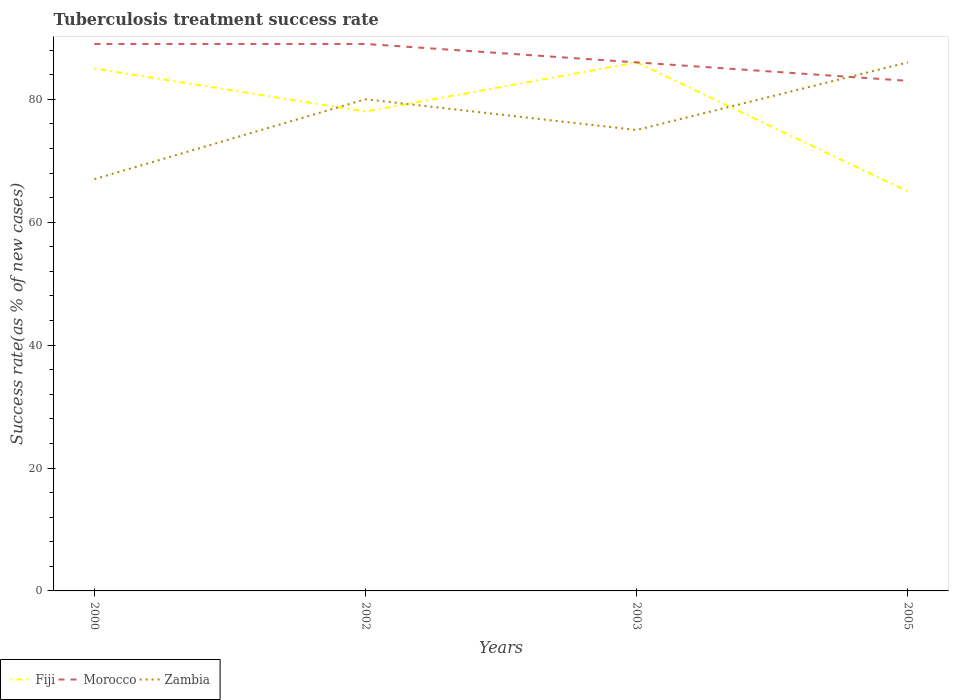How many different coloured lines are there?
Your answer should be compact. 3. Across all years, what is the maximum tuberculosis treatment success rate in Morocco?
Keep it short and to the point. 83. What is the total tuberculosis treatment success rate in Morocco in the graph?
Keep it short and to the point. 3. What is the difference between the highest and the second highest tuberculosis treatment success rate in Morocco?
Your response must be concise. 6. What is the difference between the highest and the lowest tuberculosis treatment success rate in Fiji?
Offer a very short reply. 2. Is the tuberculosis treatment success rate in Zambia strictly greater than the tuberculosis treatment success rate in Morocco over the years?
Offer a terse response. No. How many lines are there?
Give a very brief answer. 3. Does the graph contain grids?
Ensure brevity in your answer.  No. Where does the legend appear in the graph?
Make the answer very short. Bottom left. How many legend labels are there?
Make the answer very short. 3. What is the title of the graph?
Your answer should be very brief. Tuberculosis treatment success rate. What is the label or title of the X-axis?
Your answer should be very brief. Years. What is the label or title of the Y-axis?
Offer a terse response. Success rate(as % of new cases). What is the Success rate(as % of new cases) of Morocco in 2000?
Give a very brief answer. 89. What is the Success rate(as % of new cases) of Fiji in 2002?
Offer a terse response. 78. What is the Success rate(as % of new cases) in Morocco in 2002?
Give a very brief answer. 89. What is the Success rate(as % of new cases) in Zambia in 2003?
Provide a succinct answer. 75. What is the Success rate(as % of new cases) of Fiji in 2005?
Make the answer very short. 65. What is the Success rate(as % of new cases) in Zambia in 2005?
Your response must be concise. 86. Across all years, what is the maximum Success rate(as % of new cases) of Morocco?
Keep it short and to the point. 89. Across all years, what is the maximum Success rate(as % of new cases) in Zambia?
Offer a very short reply. 86. What is the total Success rate(as % of new cases) in Fiji in the graph?
Offer a terse response. 314. What is the total Success rate(as % of new cases) of Morocco in the graph?
Make the answer very short. 347. What is the total Success rate(as % of new cases) of Zambia in the graph?
Make the answer very short. 308. What is the difference between the Success rate(as % of new cases) of Fiji in 2000 and that in 2002?
Offer a very short reply. 7. What is the difference between the Success rate(as % of new cases) in Morocco in 2000 and that in 2002?
Offer a terse response. 0. What is the difference between the Success rate(as % of new cases) of Zambia in 2000 and that in 2002?
Provide a succinct answer. -13. What is the difference between the Success rate(as % of new cases) of Fiji in 2000 and that in 2003?
Provide a short and direct response. -1. What is the difference between the Success rate(as % of new cases) in Zambia in 2000 and that in 2003?
Give a very brief answer. -8. What is the difference between the Success rate(as % of new cases) in Fiji in 2000 and that in 2005?
Provide a succinct answer. 20. What is the difference between the Success rate(as % of new cases) of Zambia in 2000 and that in 2005?
Provide a succinct answer. -19. What is the difference between the Success rate(as % of new cases) in Morocco in 2002 and that in 2003?
Your answer should be very brief. 3. What is the difference between the Success rate(as % of new cases) in Fiji in 2002 and that in 2005?
Provide a succinct answer. 13. What is the difference between the Success rate(as % of new cases) of Morocco in 2002 and that in 2005?
Offer a terse response. 6. What is the difference between the Success rate(as % of new cases) of Zambia in 2002 and that in 2005?
Provide a succinct answer. -6. What is the difference between the Success rate(as % of new cases) in Morocco in 2003 and that in 2005?
Your answer should be compact. 3. What is the difference between the Success rate(as % of new cases) of Zambia in 2003 and that in 2005?
Provide a succinct answer. -11. What is the difference between the Success rate(as % of new cases) of Fiji in 2000 and the Success rate(as % of new cases) of Zambia in 2002?
Give a very brief answer. 5. What is the difference between the Success rate(as % of new cases) of Fiji in 2000 and the Success rate(as % of new cases) of Morocco in 2003?
Ensure brevity in your answer.  -1. What is the difference between the Success rate(as % of new cases) of Fiji in 2000 and the Success rate(as % of new cases) of Zambia in 2003?
Ensure brevity in your answer.  10. What is the difference between the Success rate(as % of new cases) in Morocco in 2000 and the Success rate(as % of new cases) in Zambia in 2005?
Your response must be concise. 3. What is the difference between the Success rate(as % of new cases) of Fiji in 2002 and the Success rate(as % of new cases) of Morocco in 2005?
Make the answer very short. -5. What is the difference between the Success rate(as % of new cases) in Fiji in 2002 and the Success rate(as % of new cases) in Zambia in 2005?
Offer a very short reply. -8. What is the difference between the Success rate(as % of new cases) of Fiji in 2003 and the Success rate(as % of new cases) of Zambia in 2005?
Provide a short and direct response. 0. What is the difference between the Success rate(as % of new cases) in Morocco in 2003 and the Success rate(as % of new cases) in Zambia in 2005?
Your response must be concise. 0. What is the average Success rate(as % of new cases) of Fiji per year?
Give a very brief answer. 78.5. What is the average Success rate(as % of new cases) in Morocco per year?
Your answer should be compact. 86.75. In the year 2000, what is the difference between the Success rate(as % of new cases) of Fiji and Success rate(as % of new cases) of Morocco?
Ensure brevity in your answer.  -4. In the year 2000, what is the difference between the Success rate(as % of new cases) in Fiji and Success rate(as % of new cases) in Zambia?
Offer a very short reply. 18. In the year 2000, what is the difference between the Success rate(as % of new cases) in Morocco and Success rate(as % of new cases) in Zambia?
Ensure brevity in your answer.  22. In the year 2002, what is the difference between the Success rate(as % of new cases) in Fiji and Success rate(as % of new cases) in Zambia?
Your answer should be compact. -2. In the year 2002, what is the difference between the Success rate(as % of new cases) of Morocco and Success rate(as % of new cases) of Zambia?
Your answer should be very brief. 9. In the year 2003, what is the difference between the Success rate(as % of new cases) in Fiji and Success rate(as % of new cases) in Zambia?
Offer a terse response. 11. In the year 2005, what is the difference between the Success rate(as % of new cases) of Fiji and Success rate(as % of new cases) of Morocco?
Your response must be concise. -18. In the year 2005, what is the difference between the Success rate(as % of new cases) in Fiji and Success rate(as % of new cases) in Zambia?
Provide a succinct answer. -21. In the year 2005, what is the difference between the Success rate(as % of new cases) of Morocco and Success rate(as % of new cases) of Zambia?
Provide a short and direct response. -3. What is the ratio of the Success rate(as % of new cases) in Fiji in 2000 to that in 2002?
Ensure brevity in your answer.  1.09. What is the ratio of the Success rate(as % of new cases) in Zambia in 2000 to that in 2002?
Offer a terse response. 0.84. What is the ratio of the Success rate(as % of new cases) of Fiji in 2000 to that in 2003?
Offer a terse response. 0.99. What is the ratio of the Success rate(as % of new cases) of Morocco in 2000 to that in 2003?
Provide a short and direct response. 1.03. What is the ratio of the Success rate(as % of new cases) of Zambia in 2000 to that in 2003?
Make the answer very short. 0.89. What is the ratio of the Success rate(as % of new cases) in Fiji in 2000 to that in 2005?
Your response must be concise. 1.31. What is the ratio of the Success rate(as % of new cases) of Morocco in 2000 to that in 2005?
Your response must be concise. 1.07. What is the ratio of the Success rate(as % of new cases) of Zambia in 2000 to that in 2005?
Give a very brief answer. 0.78. What is the ratio of the Success rate(as % of new cases) of Fiji in 2002 to that in 2003?
Your answer should be very brief. 0.91. What is the ratio of the Success rate(as % of new cases) in Morocco in 2002 to that in 2003?
Your answer should be compact. 1.03. What is the ratio of the Success rate(as % of new cases) in Zambia in 2002 to that in 2003?
Make the answer very short. 1.07. What is the ratio of the Success rate(as % of new cases) in Morocco in 2002 to that in 2005?
Offer a terse response. 1.07. What is the ratio of the Success rate(as % of new cases) in Zambia in 2002 to that in 2005?
Keep it short and to the point. 0.93. What is the ratio of the Success rate(as % of new cases) in Fiji in 2003 to that in 2005?
Ensure brevity in your answer.  1.32. What is the ratio of the Success rate(as % of new cases) of Morocco in 2003 to that in 2005?
Offer a very short reply. 1.04. What is the ratio of the Success rate(as % of new cases) of Zambia in 2003 to that in 2005?
Ensure brevity in your answer.  0.87. What is the difference between the highest and the second highest Success rate(as % of new cases) in Morocco?
Your answer should be compact. 0. What is the difference between the highest and the second highest Success rate(as % of new cases) of Zambia?
Provide a succinct answer. 6. 